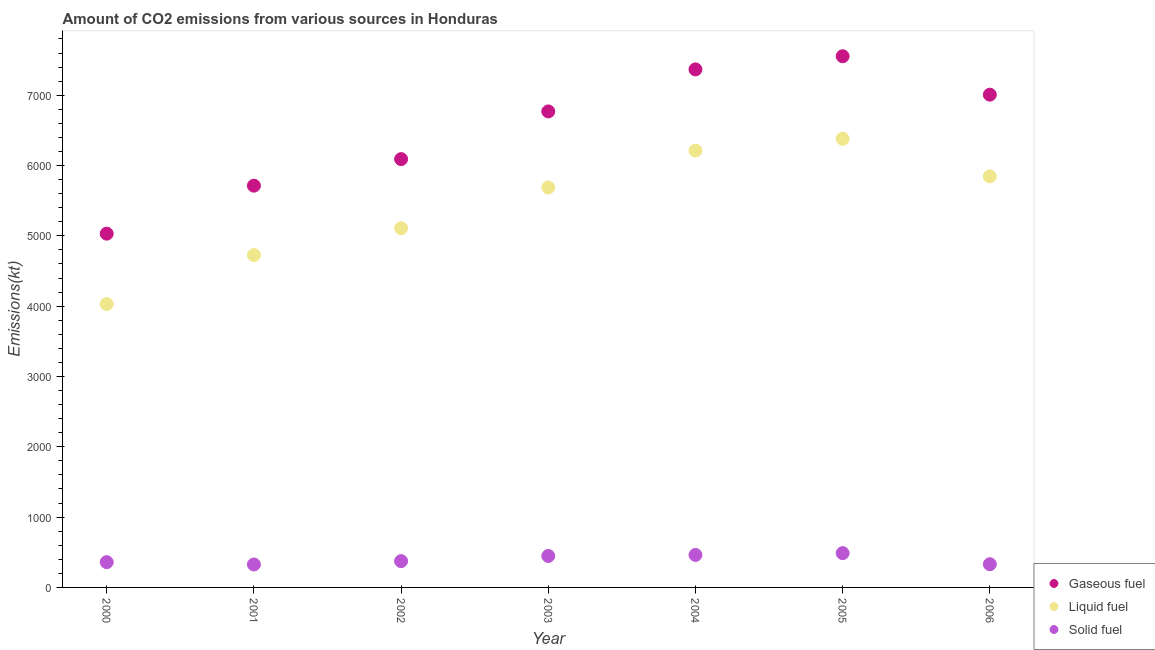How many different coloured dotlines are there?
Offer a very short reply. 3. What is the amount of co2 emissions from solid fuel in 2003?
Ensure brevity in your answer.  447.37. Across all years, what is the maximum amount of co2 emissions from solid fuel?
Provide a short and direct response. 487.71. Across all years, what is the minimum amount of co2 emissions from gaseous fuel?
Give a very brief answer. 5031.12. In which year was the amount of co2 emissions from gaseous fuel maximum?
Your response must be concise. 2005. What is the total amount of co2 emissions from solid fuel in the graph?
Provide a short and direct response. 2786.92. What is the difference between the amount of co2 emissions from solid fuel in 2001 and that in 2005?
Provide a succinct answer. -161.35. What is the difference between the amount of co2 emissions from liquid fuel in 2001 and the amount of co2 emissions from gaseous fuel in 2000?
Offer a very short reply. -304.36. What is the average amount of co2 emissions from solid fuel per year?
Your answer should be compact. 398.13. In the year 2001, what is the difference between the amount of co2 emissions from solid fuel and amount of co2 emissions from gaseous fuel?
Keep it short and to the point. -5386.82. What is the ratio of the amount of co2 emissions from solid fuel in 2001 to that in 2006?
Give a very brief answer. 0.99. What is the difference between the highest and the second highest amount of co2 emissions from solid fuel?
Your answer should be very brief. 25.67. What is the difference between the highest and the lowest amount of co2 emissions from solid fuel?
Provide a succinct answer. 161.35. In how many years, is the amount of co2 emissions from solid fuel greater than the average amount of co2 emissions from solid fuel taken over all years?
Your answer should be very brief. 3. Is the amount of co2 emissions from gaseous fuel strictly greater than the amount of co2 emissions from liquid fuel over the years?
Offer a terse response. Yes. Is the amount of co2 emissions from solid fuel strictly less than the amount of co2 emissions from gaseous fuel over the years?
Ensure brevity in your answer.  Yes. How many dotlines are there?
Your response must be concise. 3. Does the graph contain any zero values?
Offer a very short reply. No. Does the graph contain grids?
Provide a short and direct response. No. What is the title of the graph?
Give a very brief answer. Amount of CO2 emissions from various sources in Honduras. What is the label or title of the X-axis?
Give a very brief answer. Year. What is the label or title of the Y-axis?
Make the answer very short. Emissions(kt). What is the Emissions(kt) in Gaseous fuel in 2000?
Offer a very short reply. 5031.12. What is the Emissions(kt) in Liquid fuel in 2000?
Provide a short and direct response. 4030.03. What is the Emissions(kt) in Solid fuel in 2000?
Give a very brief answer. 359.37. What is the Emissions(kt) of Gaseous fuel in 2001?
Give a very brief answer. 5713.19. What is the Emissions(kt) in Liquid fuel in 2001?
Your answer should be compact. 4726.76. What is the Emissions(kt) in Solid fuel in 2001?
Provide a short and direct response. 326.36. What is the Emissions(kt) of Gaseous fuel in 2002?
Make the answer very short. 6090.89. What is the Emissions(kt) of Liquid fuel in 2002?
Your answer should be compact. 5108.13. What is the Emissions(kt) in Solid fuel in 2002?
Provide a short and direct response. 374.03. What is the Emissions(kt) in Gaseous fuel in 2003?
Offer a terse response. 6769.28. What is the Emissions(kt) in Liquid fuel in 2003?
Your answer should be compact. 5687.52. What is the Emissions(kt) of Solid fuel in 2003?
Your response must be concise. 447.37. What is the Emissions(kt) in Gaseous fuel in 2004?
Provide a succinct answer. 7367. What is the Emissions(kt) in Liquid fuel in 2004?
Offer a very short reply. 6211.9. What is the Emissions(kt) of Solid fuel in 2004?
Your answer should be compact. 462.04. What is the Emissions(kt) in Gaseous fuel in 2005?
Your response must be concise. 7554.02. What is the Emissions(kt) of Liquid fuel in 2005?
Your answer should be compact. 6380.58. What is the Emissions(kt) of Solid fuel in 2005?
Make the answer very short. 487.71. What is the Emissions(kt) of Gaseous fuel in 2006?
Keep it short and to the point. 7007.64. What is the Emissions(kt) of Liquid fuel in 2006?
Offer a very short reply. 5845.2. What is the Emissions(kt) in Solid fuel in 2006?
Provide a succinct answer. 330.03. Across all years, what is the maximum Emissions(kt) of Gaseous fuel?
Offer a terse response. 7554.02. Across all years, what is the maximum Emissions(kt) in Liquid fuel?
Make the answer very short. 6380.58. Across all years, what is the maximum Emissions(kt) in Solid fuel?
Give a very brief answer. 487.71. Across all years, what is the minimum Emissions(kt) of Gaseous fuel?
Provide a short and direct response. 5031.12. Across all years, what is the minimum Emissions(kt) in Liquid fuel?
Provide a short and direct response. 4030.03. Across all years, what is the minimum Emissions(kt) in Solid fuel?
Your response must be concise. 326.36. What is the total Emissions(kt) in Gaseous fuel in the graph?
Your response must be concise. 4.55e+04. What is the total Emissions(kt) in Liquid fuel in the graph?
Provide a short and direct response. 3.80e+04. What is the total Emissions(kt) of Solid fuel in the graph?
Your response must be concise. 2786.92. What is the difference between the Emissions(kt) of Gaseous fuel in 2000 and that in 2001?
Provide a succinct answer. -682.06. What is the difference between the Emissions(kt) of Liquid fuel in 2000 and that in 2001?
Offer a terse response. -696.73. What is the difference between the Emissions(kt) of Solid fuel in 2000 and that in 2001?
Offer a very short reply. 33. What is the difference between the Emissions(kt) of Gaseous fuel in 2000 and that in 2002?
Your response must be concise. -1059.76. What is the difference between the Emissions(kt) of Liquid fuel in 2000 and that in 2002?
Offer a terse response. -1078.1. What is the difference between the Emissions(kt) in Solid fuel in 2000 and that in 2002?
Give a very brief answer. -14.67. What is the difference between the Emissions(kt) in Gaseous fuel in 2000 and that in 2003?
Provide a succinct answer. -1738.16. What is the difference between the Emissions(kt) in Liquid fuel in 2000 and that in 2003?
Your answer should be very brief. -1657.48. What is the difference between the Emissions(kt) in Solid fuel in 2000 and that in 2003?
Provide a succinct answer. -88.01. What is the difference between the Emissions(kt) in Gaseous fuel in 2000 and that in 2004?
Your answer should be very brief. -2335.88. What is the difference between the Emissions(kt) of Liquid fuel in 2000 and that in 2004?
Keep it short and to the point. -2181.86. What is the difference between the Emissions(kt) of Solid fuel in 2000 and that in 2004?
Provide a succinct answer. -102.68. What is the difference between the Emissions(kt) of Gaseous fuel in 2000 and that in 2005?
Your answer should be very brief. -2522.9. What is the difference between the Emissions(kt) of Liquid fuel in 2000 and that in 2005?
Offer a very short reply. -2350.55. What is the difference between the Emissions(kt) in Solid fuel in 2000 and that in 2005?
Offer a very short reply. -128.34. What is the difference between the Emissions(kt) of Gaseous fuel in 2000 and that in 2006?
Your answer should be compact. -1976.51. What is the difference between the Emissions(kt) of Liquid fuel in 2000 and that in 2006?
Provide a succinct answer. -1815.16. What is the difference between the Emissions(kt) in Solid fuel in 2000 and that in 2006?
Offer a very short reply. 29.34. What is the difference between the Emissions(kt) in Gaseous fuel in 2001 and that in 2002?
Your response must be concise. -377.7. What is the difference between the Emissions(kt) of Liquid fuel in 2001 and that in 2002?
Provide a short and direct response. -381.37. What is the difference between the Emissions(kt) in Solid fuel in 2001 and that in 2002?
Give a very brief answer. -47.67. What is the difference between the Emissions(kt) of Gaseous fuel in 2001 and that in 2003?
Provide a succinct answer. -1056.1. What is the difference between the Emissions(kt) of Liquid fuel in 2001 and that in 2003?
Offer a terse response. -960.75. What is the difference between the Emissions(kt) in Solid fuel in 2001 and that in 2003?
Your answer should be very brief. -121.01. What is the difference between the Emissions(kt) in Gaseous fuel in 2001 and that in 2004?
Provide a succinct answer. -1653.82. What is the difference between the Emissions(kt) of Liquid fuel in 2001 and that in 2004?
Ensure brevity in your answer.  -1485.13. What is the difference between the Emissions(kt) of Solid fuel in 2001 and that in 2004?
Ensure brevity in your answer.  -135.68. What is the difference between the Emissions(kt) of Gaseous fuel in 2001 and that in 2005?
Make the answer very short. -1840.83. What is the difference between the Emissions(kt) in Liquid fuel in 2001 and that in 2005?
Your answer should be compact. -1653.82. What is the difference between the Emissions(kt) in Solid fuel in 2001 and that in 2005?
Offer a terse response. -161.35. What is the difference between the Emissions(kt) of Gaseous fuel in 2001 and that in 2006?
Keep it short and to the point. -1294.45. What is the difference between the Emissions(kt) of Liquid fuel in 2001 and that in 2006?
Your answer should be very brief. -1118.43. What is the difference between the Emissions(kt) in Solid fuel in 2001 and that in 2006?
Give a very brief answer. -3.67. What is the difference between the Emissions(kt) in Gaseous fuel in 2002 and that in 2003?
Make the answer very short. -678.39. What is the difference between the Emissions(kt) in Liquid fuel in 2002 and that in 2003?
Ensure brevity in your answer.  -579.39. What is the difference between the Emissions(kt) in Solid fuel in 2002 and that in 2003?
Your answer should be compact. -73.34. What is the difference between the Emissions(kt) of Gaseous fuel in 2002 and that in 2004?
Make the answer very short. -1276.12. What is the difference between the Emissions(kt) in Liquid fuel in 2002 and that in 2004?
Ensure brevity in your answer.  -1103.77. What is the difference between the Emissions(kt) in Solid fuel in 2002 and that in 2004?
Provide a succinct answer. -88.01. What is the difference between the Emissions(kt) of Gaseous fuel in 2002 and that in 2005?
Provide a succinct answer. -1463.13. What is the difference between the Emissions(kt) in Liquid fuel in 2002 and that in 2005?
Keep it short and to the point. -1272.45. What is the difference between the Emissions(kt) in Solid fuel in 2002 and that in 2005?
Provide a succinct answer. -113.68. What is the difference between the Emissions(kt) in Gaseous fuel in 2002 and that in 2006?
Keep it short and to the point. -916.75. What is the difference between the Emissions(kt) in Liquid fuel in 2002 and that in 2006?
Offer a terse response. -737.07. What is the difference between the Emissions(kt) of Solid fuel in 2002 and that in 2006?
Keep it short and to the point. 44. What is the difference between the Emissions(kt) of Gaseous fuel in 2003 and that in 2004?
Your answer should be very brief. -597.72. What is the difference between the Emissions(kt) in Liquid fuel in 2003 and that in 2004?
Ensure brevity in your answer.  -524.38. What is the difference between the Emissions(kt) in Solid fuel in 2003 and that in 2004?
Ensure brevity in your answer.  -14.67. What is the difference between the Emissions(kt) of Gaseous fuel in 2003 and that in 2005?
Ensure brevity in your answer.  -784.74. What is the difference between the Emissions(kt) of Liquid fuel in 2003 and that in 2005?
Offer a very short reply. -693.06. What is the difference between the Emissions(kt) of Solid fuel in 2003 and that in 2005?
Make the answer very short. -40.34. What is the difference between the Emissions(kt) in Gaseous fuel in 2003 and that in 2006?
Offer a terse response. -238.35. What is the difference between the Emissions(kt) of Liquid fuel in 2003 and that in 2006?
Provide a succinct answer. -157.68. What is the difference between the Emissions(kt) in Solid fuel in 2003 and that in 2006?
Your response must be concise. 117.34. What is the difference between the Emissions(kt) of Gaseous fuel in 2004 and that in 2005?
Provide a succinct answer. -187.02. What is the difference between the Emissions(kt) in Liquid fuel in 2004 and that in 2005?
Your answer should be compact. -168.68. What is the difference between the Emissions(kt) of Solid fuel in 2004 and that in 2005?
Your answer should be compact. -25.67. What is the difference between the Emissions(kt) of Gaseous fuel in 2004 and that in 2006?
Make the answer very short. 359.37. What is the difference between the Emissions(kt) in Liquid fuel in 2004 and that in 2006?
Make the answer very short. 366.7. What is the difference between the Emissions(kt) of Solid fuel in 2004 and that in 2006?
Your response must be concise. 132.01. What is the difference between the Emissions(kt) of Gaseous fuel in 2005 and that in 2006?
Your answer should be very brief. 546.38. What is the difference between the Emissions(kt) of Liquid fuel in 2005 and that in 2006?
Make the answer very short. 535.38. What is the difference between the Emissions(kt) in Solid fuel in 2005 and that in 2006?
Make the answer very short. 157.68. What is the difference between the Emissions(kt) of Gaseous fuel in 2000 and the Emissions(kt) of Liquid fuel in 2001?
Provide a succinct answer. 304.36. What is the difference between the Emissions(kt) of Gaseous fuel in 2000 and the Emissions(kt) of Solid fuel in 2001?
Your answer should be compact. 4704.76. What is the difference between the Emissions(kt) in Liquid fuel in 2000 and the Emissions(kt) in Solid fuel in 2001?
Ensure brevity in your answer.  3703.67. What is the difference between the Emissions(kt) in Gaseous fuel in 2000 and the Emissions(kt) in Liquid fuel in 2002?
Provide a succinct answer. -77.01. What is the difference between the Emissions(kt) in Gaseous fuel in 2000 and the Emissions(kt) in Solid fuel in 2002?
Your answer should be compact. 4657.09. What is the difference between the Emissions(kt) of Liquid fuel in 2000 and the Emissions(kt) of Solid fuel in 2002?
Offer a terse response. 3656. What is the difference between the Emissions(kt) in Gaseous fuel in 2000 and the Emissions(kt) in Liquid fuel in 2003?
Your answer should be compact. -656.39. What is the difference between the Emissions(kt) of Gaseous fuel in 2000 and the Emissions(kt) of Solid fuel in 2003?
Make the answer very short. 4583.75. What is the difference between the Emissions(kt) in Liquid fuel in 2000 and the Emissions(kt) in Solid fuel in 2003?
Offer a very short reply. 3582.66. What is the difference between the Emissions(kt) of Gaseous fuel in 2000 and the Emissions(kt) of Liquid fuel in 2004?
Keep it short and to the point. -1180.77. What is the difference between the Emissions(kt) of Gaseous fuel in 2000 and the Emissions(kt) of Solid fuel in 2004?
Your answer should be very brief. 4569.08. What is the difference between the Emissions(kt) of Liquid fuel in 2000 and the Emissions(kt) of Solid fuel in 2004?
Provide a succinct answer. 3567.99. What is the difference between the Emissions(kt) of Gaseous fuel in 2000 and the Emissions(kt) of Liquid fuel in 2005?
Offer a very short reply. -1349.46. What is the difference between the Emissions(kt) of Gaseous fuel in 2000 and the Emissions(kt) of Solid fuel in 2005?
Offer a terse response. 4543.41. What is the difference between the Emissions(kt) in Liquid fuel in 2000 and the Emissions(kt) in Solid fuel in 2005?
Your answer should be very brief. 3542.32. What is the difference between the Emissions(kt) in Gaseous fuel in 2000 and the Emissions(kt) in Liquid fuel in 2006?
Your answer should be very brief. -814.07. What is the difference between the Emissions(kt) in Gaseous fuel in 2000 and the Emissions(kt) in Solid fuel in 2006?
Keep it short and to the point. 4701.09. What is the difference between the Emissions(kt) in Liquid fuel in 2000 and the Emissions(kt) in Solid fuel in 2006?
Make the answer very short. 3700. What is the difference between the Emissions(kt) in Gaseous fuel in 2001 and the Emissions(kt) in Liquid fuel in 2002?
Your answer should be very brief. 605.05. What is the difference between the Emissions(kt) in Gaseous fuel in 2001 and the Emissions(kt) in Solid fuel in 2002?
Keep it short and to the point. 5339.15. What is the difference between the Emissions(kt) of Liquid fuel in 2001 and the Emissions(kt) of Solid fuel in 2002?
Your answer should be very brief. 4352.73. What is the difference between the Emissions(kt) of Gaseous fuel in 2001 and the Emissions(kt) of Liquid fuel in 2003?
Ensure brevity in your answer.  25.67. What is the difference between the Emissions(kt) in Gaseous fuel in 2001 and the Emissions(kt) in Solid fuel in 2003?
Keep it short and to the point. 5265.81. What is the difference between the Emissions(kt) of Liquid fuel in 2001 and the Emissions(kt) of Solid fuel in 2003?
Your answer should be compact. 4279.39. What is the difference between the Emissions(kt) of Gaseous fuel in 2001 and the Emissions(kt) of Liquid fuel in 2004?
Give a very brief answer. -498.71. What is the difference between the Emissions(kt) in Gaseous fuel in 2001 and the Emissions(kt) in Solid fuel in 2004?
Provide a short and direct response. 5251.14. What is the difference between the Emissions(kt) in Liquid fuel in 2001 and the Emissions(kt) in Solid fuel in 2004?
Your answer should be very brief. 4264.72. What is the difference between the Emissions(kt) in Gaseous fuel in 2001 and the Emissions(kt) in Liquid fuel in 2005?
Make the answer very short. -667.39. What is the difference between the Emissions(kt) of Gaseous fuel in 2001 and the Emissions(kt) of Solid fuel in 2005?
Offer a terse response. 5225.48. What is the difference between the Emissions(kt) in Liquid fuel in 2001 and the Emissions(kt) in Solid fuel in 2005?
Provide a succinct answer. 4239.05. What is the difference between the Emissions(kt) of Gaseous fuel in 2001 and the Emissions(kt) of Liquid fuel in 2006?
Ensure brevity in your answer.  -132.01. What is the difference between the Emissions(kt) in Gaseous fuel in 2001 and the Emissions(kt) in Solid fuel in 2006?
Offer a very short reply. 5383.16. What is the difference between the Emissions(kt) of Liquid fuel in 2001 and the Emissions(kt) of Solid fuel in 2006?
Provide a short and direct response. 4396.73. What is the difference between the Emissions(kt) in Gaseous fuel in 2002 and the Emissions(kt) in Liquid fuel in 2003?
Give a very brief answer. 403.37. What is the difference between the Emissions(kt) in Gaseous fuel in 2002 and the Emissions(kt) in Solid fuel in 2003?
Give a very brief answer. 5643.51. What is the difference between the Emissions(kt) in Liquid fuel in 2002 and the Emissions(kt) in Solid fuel in 2003?
Ensure brevity in your answer.  4660.76. What is the difference between the Emissions(kt) of Gaseous fuel in 2002 and the Emissions(kt) of Liquid fuel in 2004?
Your answer should be very brief. -121.01. What is the difference between the Emissions(kt) in Gaseous fuel in 2002 and the Emissions(kt) in Solid fuel in 2004?
Provide a short and direct response. 5628.85. What is the difference between the Emissions(kt) in Liquid fuel in 2002 and the Emissions(kt) in Solid fuel in 2004?
Offer a terse response. 4646.09. What is the difference between the Emissions(kt) in Gaseous fuel in 2002 and the Emissions(kt) in Liquid fuel in 2005?
Give a very brief answer. -289.69. What is the difference between the Emissions(kt) in Gaseous fuel in 2002 and the Emissions(kt) in Solid fuel in 2005?
Make the answer very short. 5603.18. What is the difference between the Emissions(kt) in Liquid fuel in 2002 and the Emissions(kt) in Solid fuel in 2005?
Keep it short and to the point. 4620.42. What is the difference between the Emissions(kt) of Gaseous fuel in 2002 and the Emissions(kt) of Liquid fuel in 2006?
Your answer should be very brief. 245.69. What is the difference between the Emissions(kt) of Gaseous fuel in 2002 and the Emissions(kt) of Solid fuel in 2006?
Offer a very short reply. 5760.86. What is the difference between the Emissions(kt) in Liquid fuel in 2002 and the Emissions(kt) in Solid fuel in 2006?
Offer a very short reply. 4778.1. What is the difference between the Emissions(kt) in Gaseous fuel in 2003 and the Emissions(kt) in Liquid fuel in 2004?
Provide a short and direct response. 557.38. What is the difference between the Emissions(kt) of Gaseous fuel in 2003 and the Emissions(kt) of Solid fuel in 2004?
Offer a terse response. 6307.24. What is the difference between the Emissions(kt) of Liquid fuel in 2003 and the Emissions(kt) of Solid fuel in 2004?
Make the answer very short. 5225.48. What is the difference between the Emissions(kt) of Gaseous fuel in 2003 and the Emissions(kt) of Liquid fuel in 2005?
Ensure brevity in your answer.  388.7. What is the difference between the Emissions(kt) in Gaseous fuel in 2003 and the Emissions(kt) in Solid fuel in 2005?
Provide a short and direct response. 6281.57. What is the difference between the Emissions(kt) in Liquid fuel in 2003 and the Emissions(kt) in Solid fuel in 2005?
Make the answer very short. 5199.81. What is the difference between the Emissions(kt) of Gaseous fuel in 2003 and the Emissions(kt) of Liquid fuel in 2006?
Keep it short and to the point. 924.08. What is the difference between the Emissions(kt) in Gaseous fuel in 2003 and the Emissions(kt) in Solid fuel in 2006?
Offer a terse response. 6439.25. What is the difference between the Emissions(kt) in Liquid fuel in 2003 and the Emissions(kt) in Solid fuel in 2006?
Provide a short and direct response. 5357.49. What is the difference between the Emissions(kt) of Gaseous fuel in 2004 and the Emissions(kt) of Liquid fuel in 2005?
Provide a short and direct response. 986.42. What is the difference between the Emissions(kt) in Gaseous fuel in 2004 and the Emissions(kt) in Solid fuel in 2005?
Your answer should be compact. 6879.29. What is the difference between the Emissions(kt) of Liquid fuel in 2004 and the Emissions(kt) of Solid fuel in 2005?
Offer a terse response. 5724.19. What is the difference between the Emissions(kt) of Gaseous fuel in 2004 and the Emissions(kt) of Liquid fuel in 2006?
Offer a terse response. 1521.81. What is the difference between the Emissions(kt) of Gaseous fuel in 2004 and the Emissions(kt) of Solid fuel in 2006?
Ensure brevity in your answer.  7036.97. What is the difference between the Emissions(kt) in Liquid fuel in 2004 and the Emissions(kt) in Solid fuel in 2006?
Make the answer very short. 5881.87. What is the difference between the Emissions(kt) of Gaseous fuel in 2005 and the Emissions(kt) of Liquid fuel in 2006?
Offer a terse response. 1708.82. What is the difference between the Emissions(kt) in Gaseous fuel in 2005 and the Emissions(kt) in Solid fuel in 2006?
Your answer should be very brief. 7223.99. What is the difference between the Emissions(kt) of Liquid fuel in 2005 and the Emissions(kt) of Solid fuel in 2006?
Your response must be concise. 6050.55. What is the average Emissions(kt) in Gaseous fuel per year?
Keep it short and to the point. 6504.73. What is the average Emissions(kt) in Liquid fuel per year?
Offer a very short reply. 5427.16. What is the average Emissions(kt) of Solid fuel per year?
Give a very brief answer. 398.13. In the year 2000, what is the difference between the Emissions(kt) of Gaseous fuel and Emissions(kt) of Liquid fuel?
Give a very brief answer. 1001.09. In the year 2000, what is the difference between the Emissions(kt) of Gaseous fuel and Emissions(kt) of Solid fuel?
Keep it short and to the point. 4671.76. In the year 2000, what is the difference between the Emissions(kt) of Liquid fuel and Emissions(kt) of Solid fuel?
Offer a very short reply. 3670.67. In the year 2001, what is the difference between the Emissions(kt) in Gaseous fuel and Emissions(kt) in Liquid fuel?
Your answer should be very brief. 986.42. In the year 2001, what is the difference between the Emissions(kt) in Gaseous fuel and Emissions(kt) in Solid fuel?
Your response must be concise. 5386.82. In the year 2001, what is the difference between the Emissions(kt) of Liquid fuel and Emissions(kt) of Solid fuel?
Provide a short and direct response. 4400.4. In the year 2002, what is the difference between the Emissions(kt) of Gaseous fuel and Emissions(kt) of Liquid fuel?
Your answer should be compact. 982.76. In the year 2002, what is the difference between the Emissions(kt) of Gaseous fuel and Emissions(kt) of Solid fuel?
Give a very brief answer. 5716.85. In the year 2002, what is the difference between the Emissions(kt) in Liquid fuel and Emissions(kt) in Solid fuel?
Your answer should be very brief. 4734.1. In the year 2003, what is the difference between the Emissions(kt) of Gaseous fuel and Emissions(kt) of Liquid fuel?
Offer a very short reply. 1081.77. In the year 2003, what is the difference between the Emissions(kt) of Gaseous fuel and Emissions(kt) of Solid fuel?
Provide a succinct answer. 6321.91. In the year 2003, what is the difference between the Emissions(kt) in Liquid fuel and Emissions(kt) in Solid fuel?
Offer a terse response. 5240.14. In the year 2004, what is the difference between the Emissions(kt) of Gaseous fuel and Emissions(kt) of Liquid fuel?
Ensure brevity in your answer.  1155.11. In the year 2004, what is the difference between the Emissions(kt) in Gaseous fuel and Emissions(kt) in Solid fuel?
Ensure brevity in your answer.  6904.96. In the year 2004, what is the difference between the Emissions(kt) in Liquid fuel and Emissions(kt) in Solid fuel?
Keep it short and to the point. 5749.86. In the year 2005, what is the difference between the Emissions(kt) in Gaseous fuel and Emissions(kt) in Liquid fuel?
Offer a terse response. 1173.44. In the year 2005, what is the difference between the Emissions(kt) in Gaseous fuel and Emissions(kt) in Solid fuel?
Your answer should be compact. 7066.31. In the year 2005, what is the difference between the Emissions(kt) of Liquid fuel and Emissions(kt) of Solid fuel?
Give a very brief answer. 5892.87. In the year 2006, what is the difference between the Emissions(kt) of Gaseous fuel and Emissions(kt) of Liquid fuel?
Provide a succinct answer. 1162.44. In the year 2006, what is the difference between the Emissions(kt) of Gaseous fuel and Emissions(kt) of Solid fuel?
Offer a terse response. 6677.61. In the year 2006, what is the difference between the Emissions(kt) of Liquid fuel and Emissions(kt) of Solid fuel?
Keep it short and to the point. 5515.17. What is the ratio of the Emissions(kt) in Gaseous fuel in 2000 to that in 2001?
Offer a terse response. 0.88. What is the ratio of the Emissions(kt) in Liquid fuel in 2000 to that in 2001?
Provide a short and direct response. 0.85. What is the ratio of the Emissions(kt) in Solid fuel in 2000 to that in 2001?
Your answer should be compact. 1.1. What is the ratio of the Emissions(kt) of Gaseous fuel in 2000 to that in 2002?
Your answer should be very brief. 0.83. What is the ratio of the Emissions(kt) in Liquid fuel in 2000 to that in 2002?
Give a very brief answer. 0.79. What is the ratio of the Emissions(kt) of Solid fuel in 2000 to that in 2002?
Your answer should be compact. 0.96. What is the ratio of the Emissions(kt) in Gaseous fuel in 2000 to that in 2003?
Provide a succinct answer. 0.74. What is the ratio of the Emissions(kt) in Liquid fuel in 2000 to that in 2003?
Ensure brevity in your answer.  0.71. What is the ratio of the Emissions(kt) in Solid fuel in 2000 to that in 2003?
Provide a succinct answer. 0.8. What is the ratio of the Emissions(kt) in Gaseous fuel in 2000 to that in 2004?
Keep it short and to the point. 0.68. What is the ratio of the Emissions(kt) in Liquid fuel in 2000 to that in 2004?
Offer a very short reply. 0.65. What is the ratio of the Emissions(kt) in Solid fuel in 2000 to that in 2004?
Offer a very short reply. 0.78. What is the ratio of the Emissions(kt) in Gaseous fuel in 2000 to that in 2005?
Provide a succinct answer. 0.67. What is the ratio of the Emissions(kt) in Liquid fuel in 2000 to that in 2005?
Give a very brief answer. 0.63. What is the ratio of the Emissions(kt) of Solid fuel in 2000 to that in 2005?
Offer a very short reply. 0.74. What is the ratio of the Emissions(kt) in Gaseous fuel in 2000 to that in 2006?
Ensure brevity in your answer.  0.72. What is the ratio of the Emissions(kt) in Liquid fuel in 2000 to that in 2006?
Provide a succinct answer. 0.69. What is the ratio of the Emissions(kt) in Solid fuel in 2000 to that in 2006?
Offer a terse response. 1.09. What is the ratio of the Emissions(kt) of Gaseous fuel in 2001 to that in 2002?
Keep it short and to the point. 0.94. What is the ratio of the Emissions(kt) of Liquid fuel in 2001 to that in 2002?
Make the answer very short. 0.93. What is the ratio of the Emissions(kt) of Solid fuel in 2001 to that in 2002?
Give a very brief answer. 0.87. What is the ratio of the Emissions(kt) of Gaseous fuel in 2001 to that in 2003?
Give a very brief answer. 0.84. What is the ratio of the Emissions(kt) in Liquid fuel in 2001 to that in 2003?
Make the answer very short. 0.83. What is the ratio of the Emissions(kt) of Solid fuel in 2001 to that in 2003?
Your response must be concise. 0.73. What is the ratio of the Emissions(kt) of Gaseous fuel in 2001 to that in 2004?
Keep it short and to the point. 0.78. What is the ratio of the Emissions(kt) of Liquid fuel in 2001 to that in 2004?
Make the answer very short. 0.76. What is the ratio of the Emissions(kt) of Solid fuel in 2001 to that in 2004?
Make the answer very short. 0.71. What is the ratio of the Emissions(kt) of Gaseous fuel in 2001 to that in 2005?
Provide a short and direct response. 0.76. What is the ratio of the Emissions(kt) of Liquid fuel in 2001 to that in 2005?
Your response must be concise. 0.74. What is the ratio of the Emissions(kt) in Solid fuel in 2001 to that in 2005?
Offer a terse response. 0.67. What is the ratio of the Emissions(kt) in Gaseous fuel in 2001 to that in 2006?
Offer a very short reply. 0.82. What is the ratio of the Emissions(kt) of Liquid fuel in 2001 to that in 2006?
Your answer should be very brief. 0.81. What is the ratio of the Emissions(kt) of Solid fuel in 2001 to that in 2006?
Give a very brief answer. 0.99. What is the ratio of the Emissions(kt) in Gaseous fuel in 2002 to that in 2003?
Offer a very short reply. 0.9. What is the ratio of the Emissions(kt) of Liquid fuel in 2002 to that in 2003?
Provide a short and direct response. 0.9. What is the ratio of the Emissions(kt) in Solid fuel in 2002 to that in 2003?
Your answer should be very brief. 0.84. What is the ratio of the Emissions(kt) in Gaseous fuel in 2002 to that in 2004?
Offer a very short reply. 0.83. What is the ratio of the Emissions(kt) of Liquid fuel in 2002 to that in 2004?
Offer a very short reply. 0.82. What is the ratio of the Emissions(kt) in Solid fuel in 2002 to that in 2004?
Your answer should be compact. 0.81. What is the ratio of the Emissions(kt) of Gaseous fuel in 2002 to that in 2005?
Keep it short and to the point. 0.81. What is the ratio of the Emissions(kt) of Liquid fuel in 2002 to that in 2005?
Your response must be concise. 0.8. What is the ratio of the Emissions(kt) in Solid fuel in 2002 to that in 2005?
Provide a short and direct response. 0.77. What is the ratio of the Emissions(kt) in Gaseous fuel in 2002 to that in 2006?
Your answer should be compact. 0.87. What is the ratio of the Emissions(kt) in Liquid fuel in 2002 to that in 2006?
Offer a terse response. 0.87. What is the ratio of the Emissions(kt) of Solid fuel in 2002 to that in 2006?
Keep it short and to the point. 1.13. What is the ratio of the Emissions(kt) in Gaseous fuel in 2003 to that in 2004?
Keep it short and to the point. 0.92. What is the ratio of the Emissions(kt) of Liquid fuel in 2003 to that in 2004?
Ensure brevity in your answer.  0.92. What is the ratio of the Emissions(kt) of Solid fuel in 2003 to that in 2004?
Provide a short and direct response. 0.97. What is the ratio of the Emissions(kt) in Gaseous fuel in 2003 to that in 2005?
Your answer should be compact. 0.9. What is the ratio of the Emissions(kt) of Liquid fuel in 2003 to that in 2005?
Offer a very short reply. 0.89. What is the ratio of the Emissions(kt) of Solid fuel in 2003 to that in 2005?
Your answer should be compact. 0.92. What is the ratio of the Emissions(kt) in Liquid fuel in 2003 to that in 2006?
Provide a succinct answer. 0.97. What is the ratio of the Emissions(kt) in Solid fuel in 2003 to that in 2006?
Give a very brief answer. 1.36. What is the ratio of the Emissions(kt) of Gaseous fuel in 2004 to that in 2005?
Your response must be concise. 0.98. What is the ratio of the Emissions(kt) of Liquid fuel in 2004 to that in 2005?
Your response must be concise. 0.97. What is the ratio of the Emissions(kt) in Solid fuel in 2004 to that in 2005?
Offer a very short reply. 0.95. What is the ratio of the Emissions(kt) in Gaseous fuel in 2004 to that in 2006?
Provide a short and direct response. 1.05. What is the ratio of the Emissions(kt) in Liquid fuel in 2004 to that in 2006?
Your response must be concise. 1.06. What is the ratio of the Emissions(kt) in Gaseous fuel in 2005 to that in 2006?
Make the answer very short. 1.08. What is the ratio of the Emissions(kt) in Liquid fuel in 2005 to that in 2006?
Your answer should be compact. 1.09. What is the ratio of the Emissions(kt) of Solid fuel in 2005 to that in 2006?
Give a very brief answer. 1.48. What is the difference between the highest and the second highest Emissions(kt) of Gaseous fuel?
Give a very brief answer. 187.02. What is the difference between the highest and the second highest Emissions(kt) of Liquid fuel?
Give a very brief answer. 168.68. What is the difference between the highest and the second highest Emissions(kt) of Solid fuel?
Give a very brief answer. 25.67. What is the difference between the highest and the lowest Emissions(kt) of Gaseous fuel?
Your answer should be very brief. 2522.9. What is the difference between the highest and the lowest Emissions(kt) in Liquid fuel?
Offer a terse response. 2350.55. What is the difference between the highest and the lowest Emissions(kt) of Solid fuel?
Offer a very short reply. 161.35. 